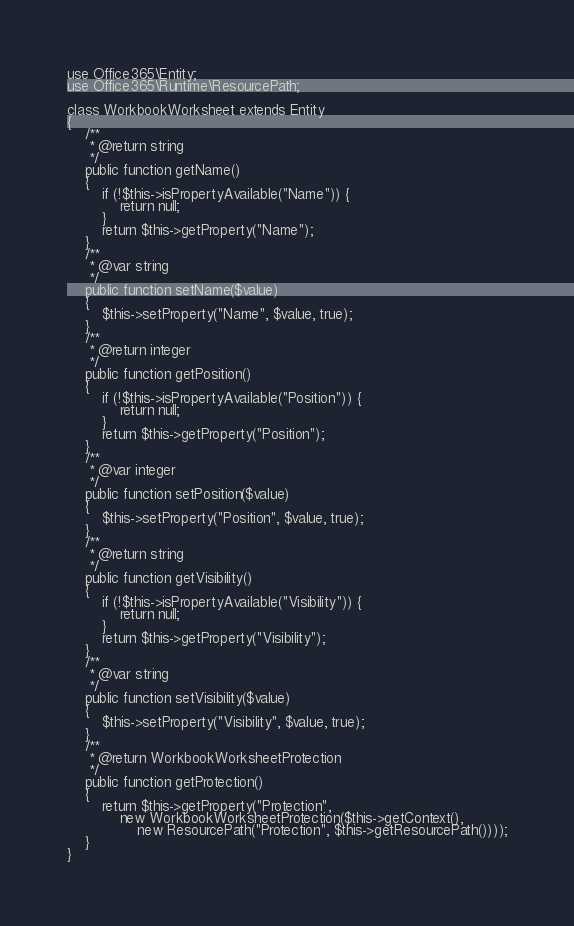<code> <loc_0><loc_0><loc_500><loc_500><_PHP_>use Office365\Entity;
use Office365\Runtime\ResourcePath;

class WorkbookWorksheet extends Entity
{
    /**
     * @return string
     */
    public function getName()
    {
        if (!$this->isPropertyAvailable("Name")) {
            return null;
        }
        return $this->getProperty("Name");
    }
    /**
     * @var string
     */
    public function setName($value)
    {
        $this->setProperty("Name", $value, true);
    }
    /**
     * @return integer
     */
    public function getPosition()
    {
        if (!$this->isPropertyAvailable("Position")) {
            return null;
        }
        return $this->getProperty("Position");
    }
    /**
     * @var integer
     */
    public function setPosition($value)
    {
        $this->setProperty("Position", $value, true);
    }
    /**
     * @return string
     */
    public function getVisibility()
    {
        if (!$this->isPropertyAvailable("Visibility")) {
            return null;
        }
        return $this->getProperty("Visibility");
    }
    /**
     * @var string
     */
    public function setVisibility($value)
    {
        $this->setProperty("Visibility", $value, true);
    }
    /**
     * @return WorkbookWorksheetProtection
     */
    public function getProtection()
    {
        return $this->getProperty("Protection",
            new WorkbookWorksheetProtection($this->getContext(),
                new ResourcePath("Protection", $this->getResourcePath())));
    }
}</code> 